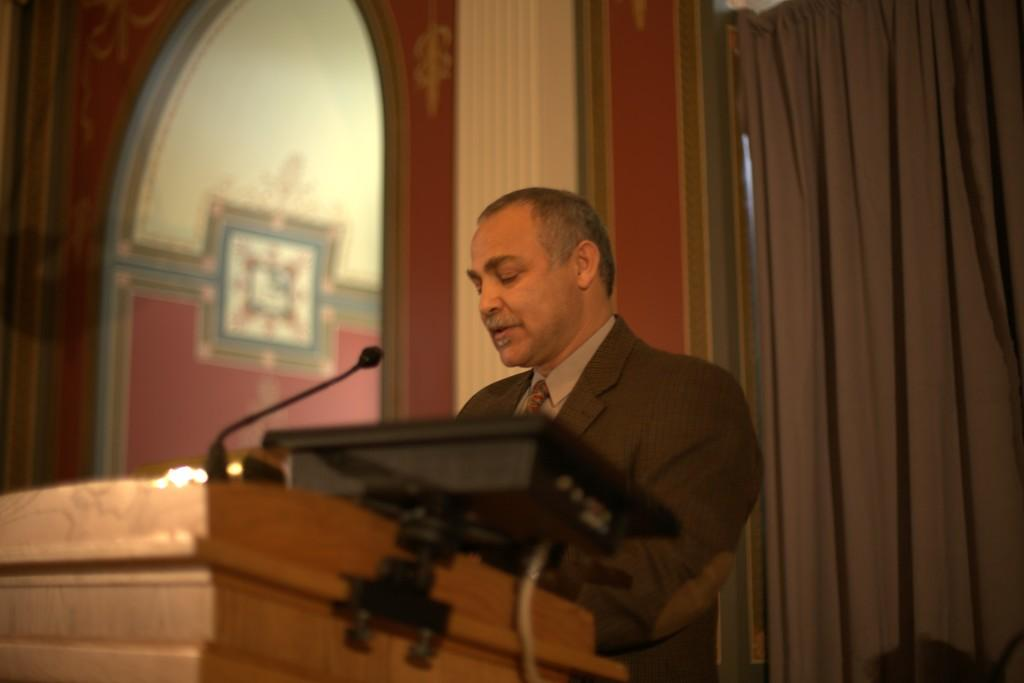Who or what is in the image? There is a person in the image. What is the person standing in front of? There is a podium in front of the person. What is the person likely to use for speaking? A microphone is present in front of the person. What can be seen behind the person? There is a curtain in the image. What type of structure is visible in the image? There is a wall visible in the image. What electronic device is present in the image? There is an electronic gadget in the image. How much money is the robin holding in the image? There is no robin present in the image, and therefore no money can be observed. 